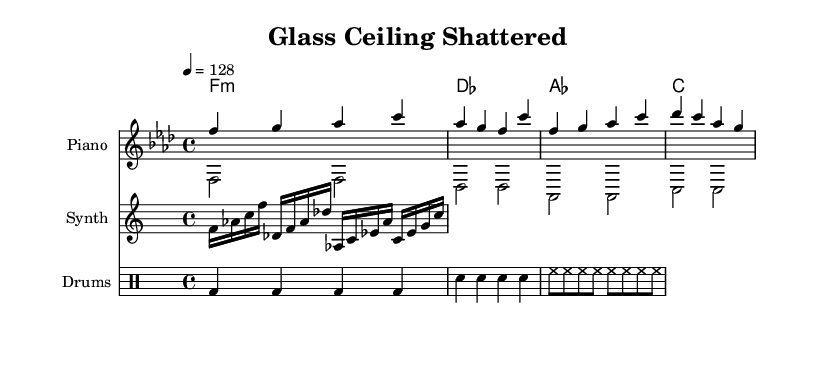What is the key signature of this music? The key signature shown in the sheet music is F minor, which contains four flats (B♭, E♭, A♭, D♭). This can be identified by looking at the key signature notation at the beginning of the staff.
Answer: F minor What is the time signature of this music? The time signature displayed in the music sheet is 4/4, which is indicated at the beginning as well. This means there are four beats in each measure, and a quarter note gets one beat.
Answer: 4/4 What is the tempo marking of this music? The tempo marking is indicated by the text "4 = 128," meaning that each quarter note is played at a speed of 128 beats per minute. This can be found in the tempo section at the beginning of the score.
Answer: 128 How many measures are in the main theme? The main theme consists of four measures, as counted by the four sets of bar lines that separate them. Each group of notes corresponds to one measure.
Answer: 4 What instruments are indicated in the score? The score indicates three instruments: "Piano," "Synth," and "Drums." This can be determined by looking at the instrument names labeled above each staff.
Answer: Piano, Synth, Drums Which chord begins the piece? The first chord indicated in the chord progression is F minor, which is displayed at the beginning of the chord names section. Each chord name corresponds to the chord played in that measure.
Answer: F minor 